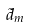<formula> <loc_0><loc_0><loc_500><loc_500>\tilde { d } _ { m }</formula> 